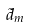<formula> <loc_0><loc_0><loc_500><loc_500>\tilde { d } _ { m }</formula> 